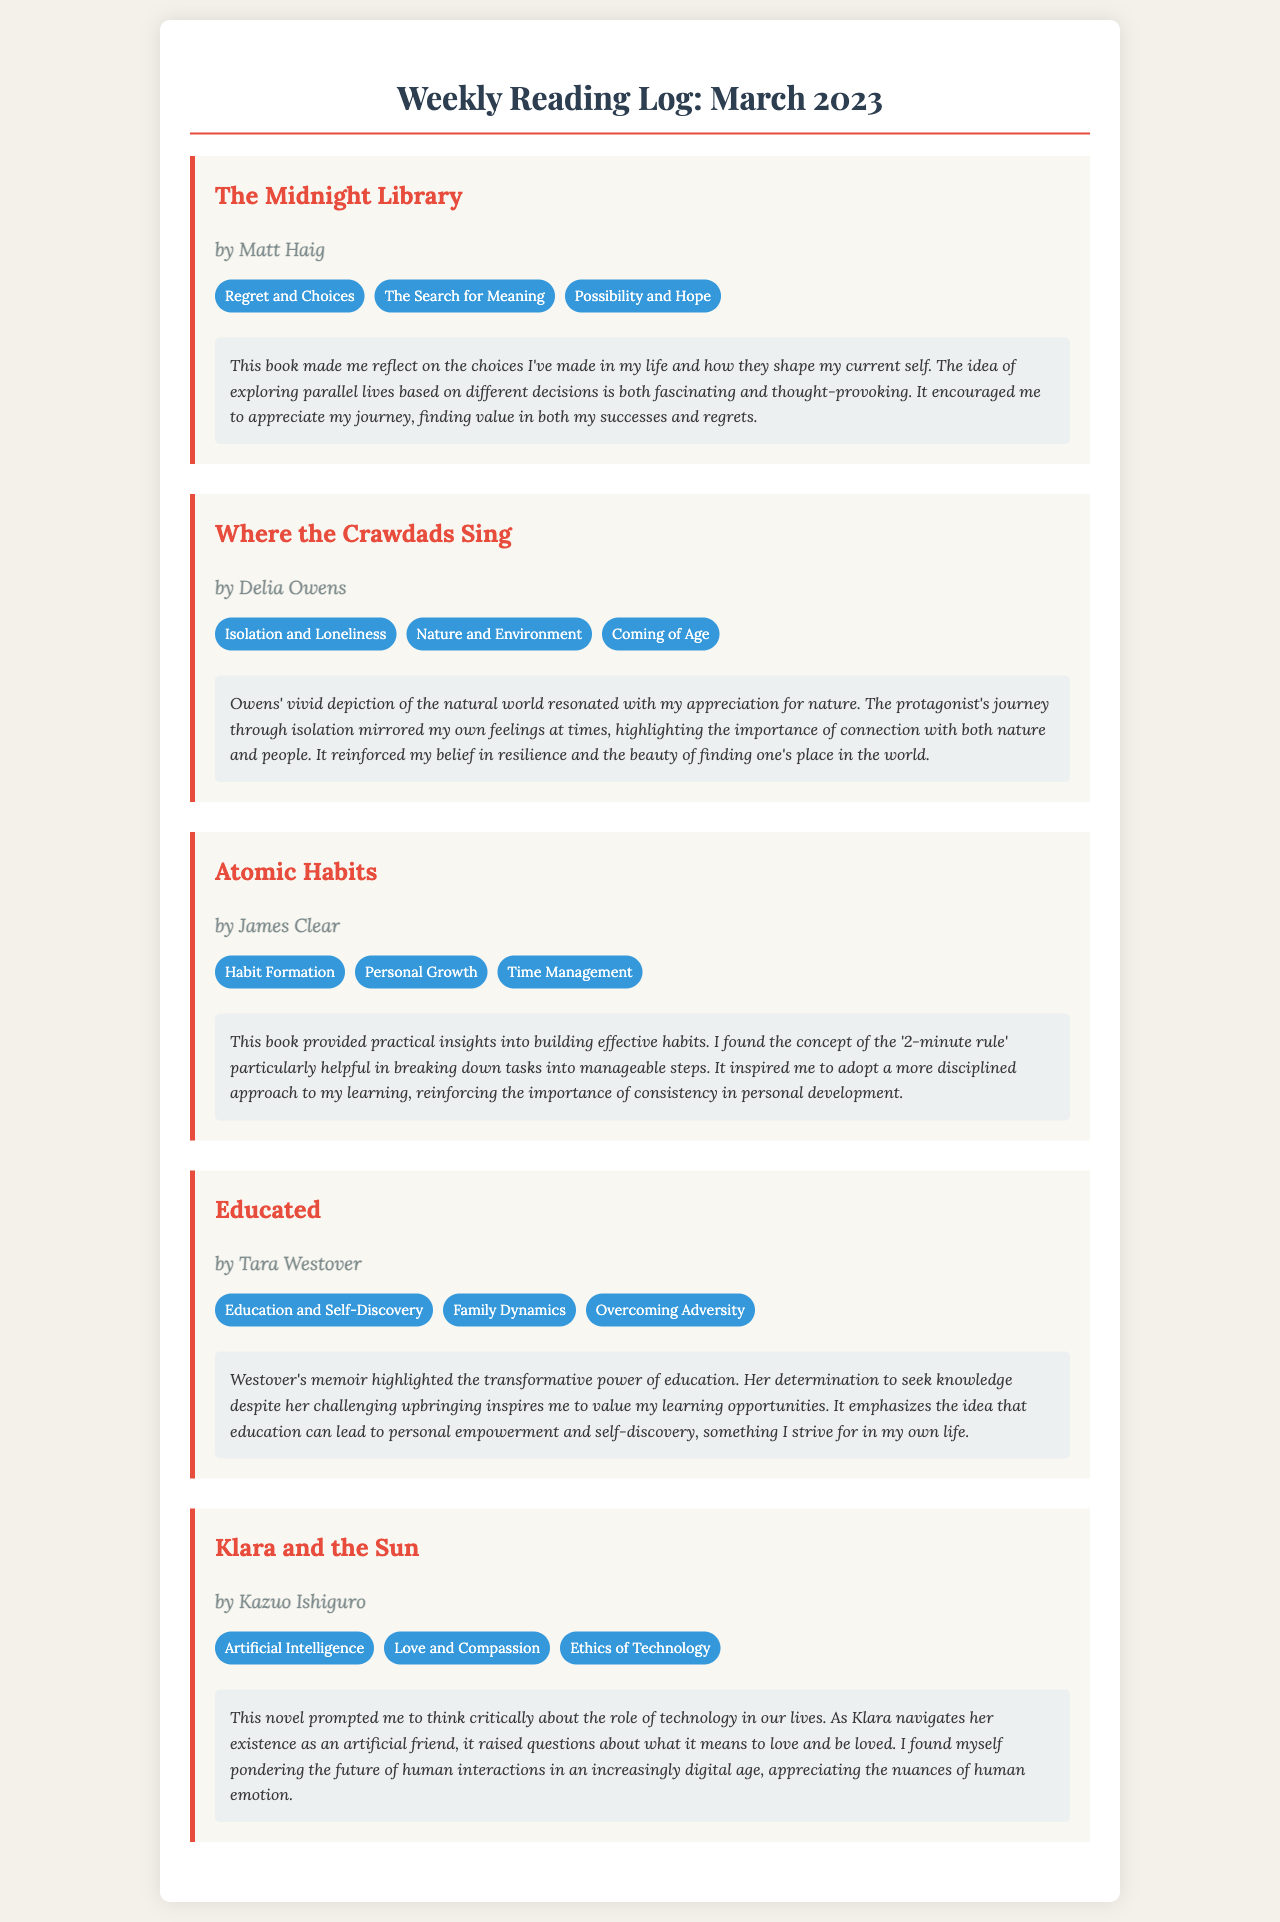What is the title of the first book listed? The title of the first book can be found at the top of the first book section in the document.
Answer: The Midnight Library Who is the author of "Atomic Habits"? The author is mentioned below the title of the book in the corresponding section.
Answer: James Clear What theme is associated with "Where the Crawdads Sing"? Each book has several themes listed in a section below the book title; one of them is selected here.
Answer: Isolation and Loneliness How many themes are listed for "Klara and the Sun"? The number of themes can be counted from the theme section of the book in the document.
Answer: Three Which book reflects on “Education and Self-Discovery”? The title can be retrieved from the respective book section where this theme is highlighted.
Answer: Educated What personal insight was gained from reading "The Midnight Library"? Reflections provided in the document summarize personal insights related to the book's themes.
Answer: Appreciate my journey What prompted reflection on technology in "Klara and the Sun"? The reflection section explains what aspects of the book led to critical thinking about technology.
Answer: The role of technology What is a recommended approach mentioned in "Atomic Habits"? The recommendation can be found in the reflection section, stating a specific method suggested by the author.
Answer: The '2-minute rule' What is the publishing month of the reading log? The document covers readings specifically for one month, which is stated prominently in the title.
Answer: March 2023 